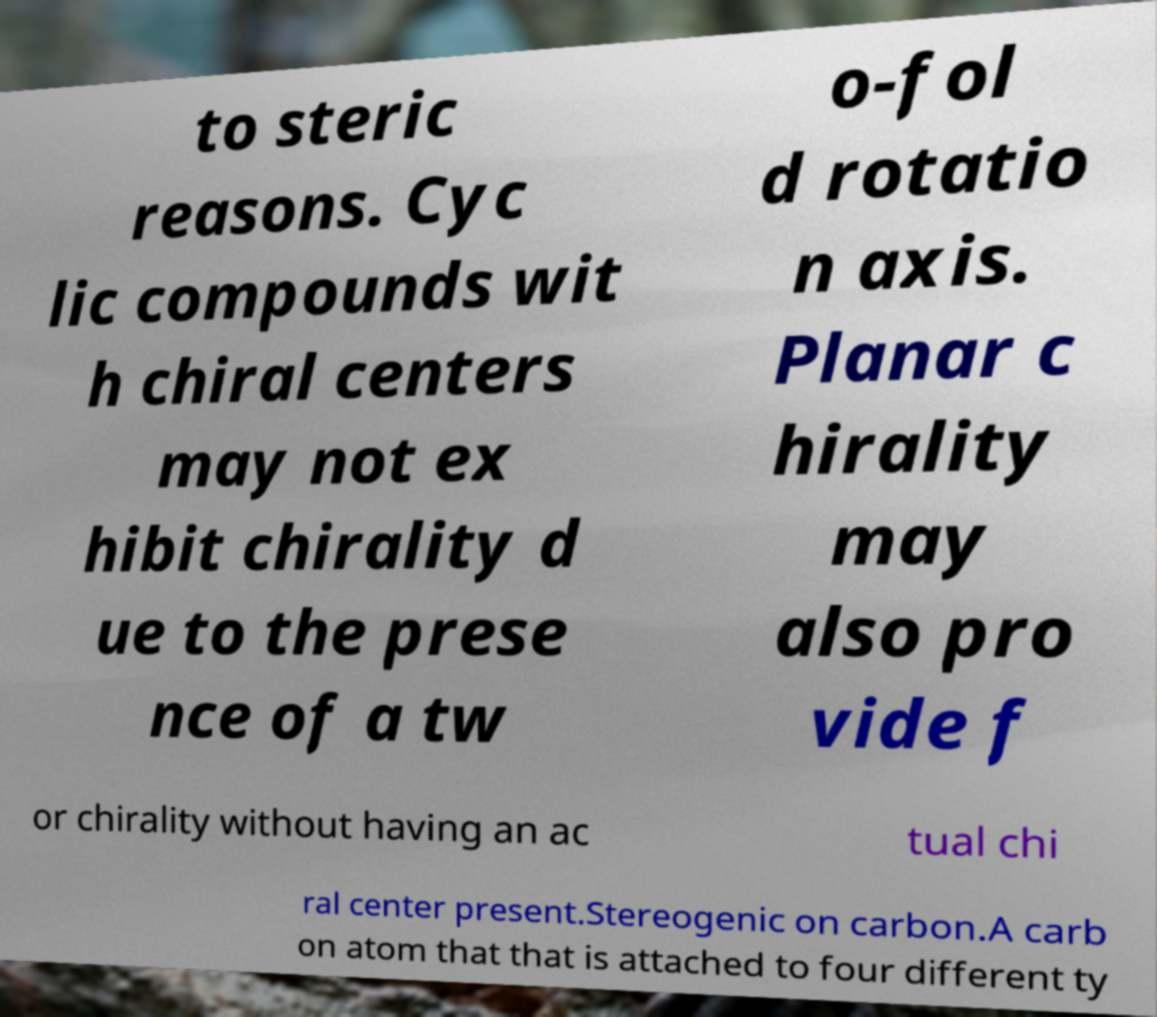Can you read and provide the text displayed in the image?This photo seems to have some interesting text. Can you extract and type it out for me? to steric reasons. Cyc lic compounds wit h chiral centers may not ex hibit chirality d ue to the prese nce of a tw o-fol d rotatio n axis. Planar c hirality may also pro vide f or chirality without having an ac tual chi ral center present.Stereogenic on carbon.A carb on atom that that is attached to four different ty 